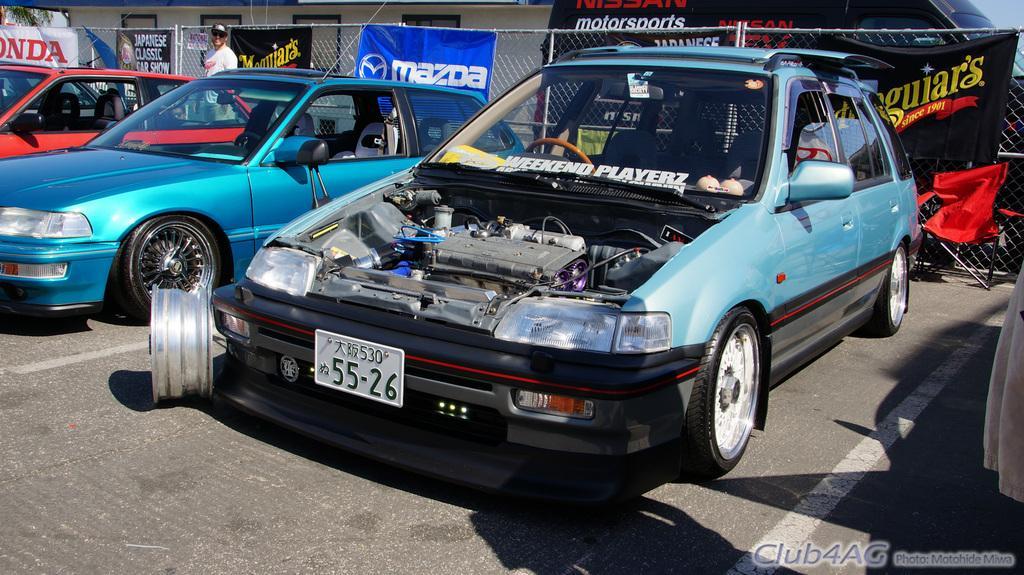Please provide a concise description of this image. In this picture there are vehicles on the road. On the left side of the image there is a person standing. At the back there are banners on the fence and there is text on the banners, Behind the fence there is a building and there is a vehicle and there is text on the vehicle and there is a tree. At the bottom there is a road. At the bottom right there is text. 